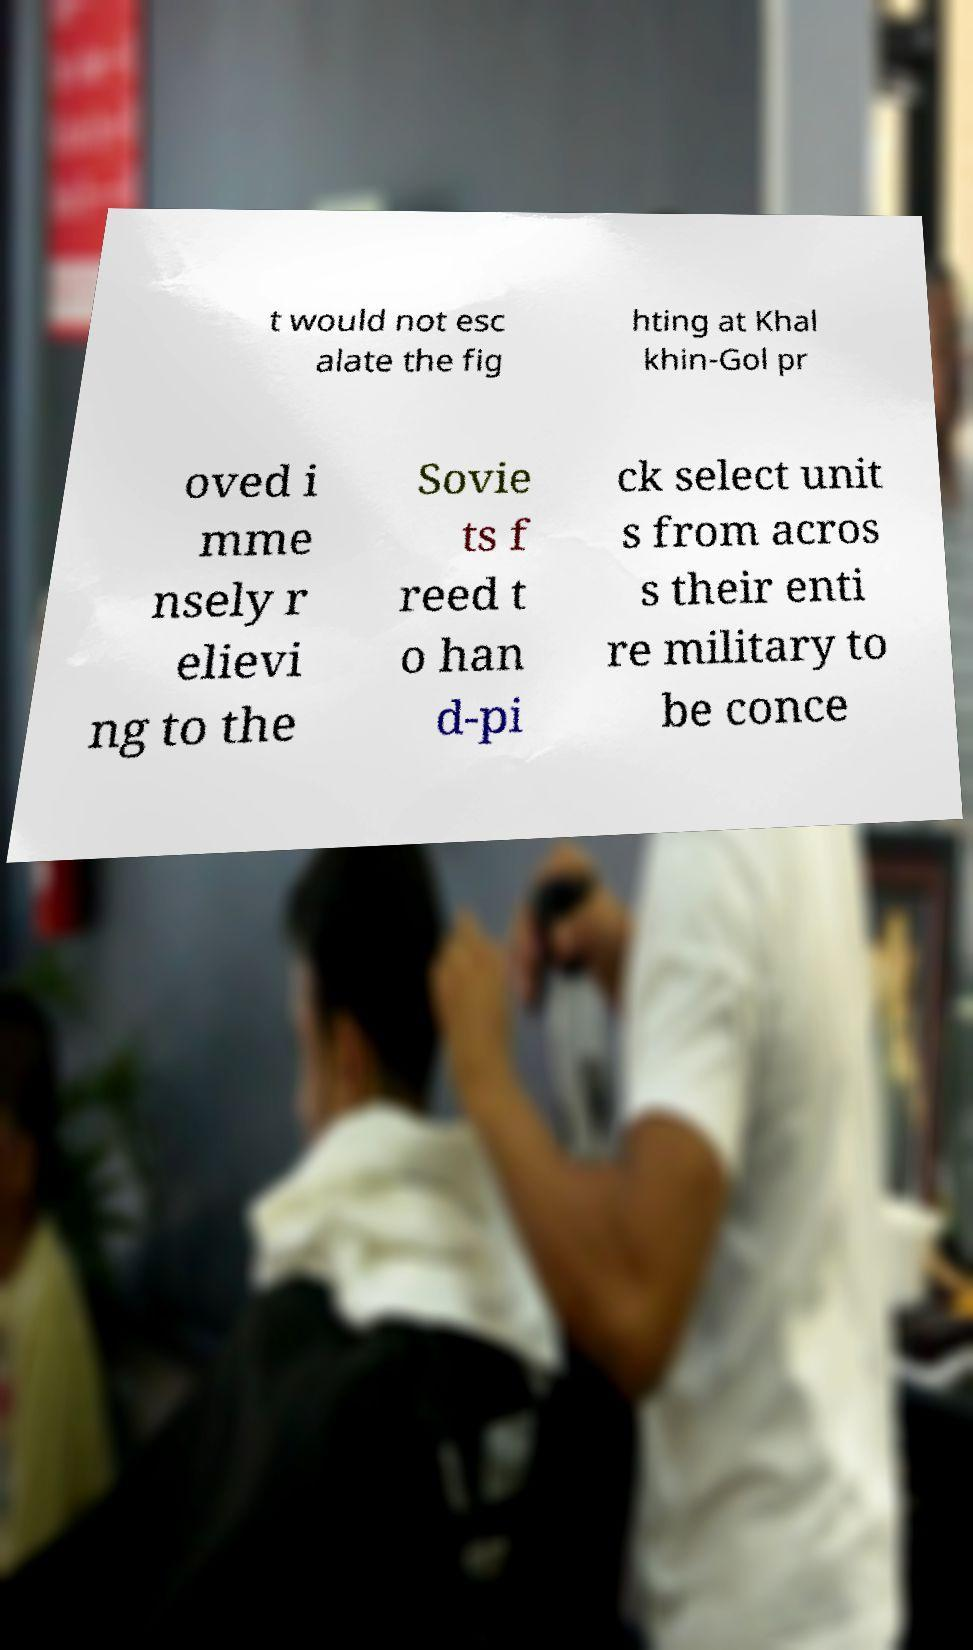Could you extract and type out the text from this image? t would not esc alate the fig hting at Khal khin-Gol pr oved i mme nsely r elievi ng to the Sovie ts f reed t o han d-pi ck select unit s from acros s their enti re military to be conce 